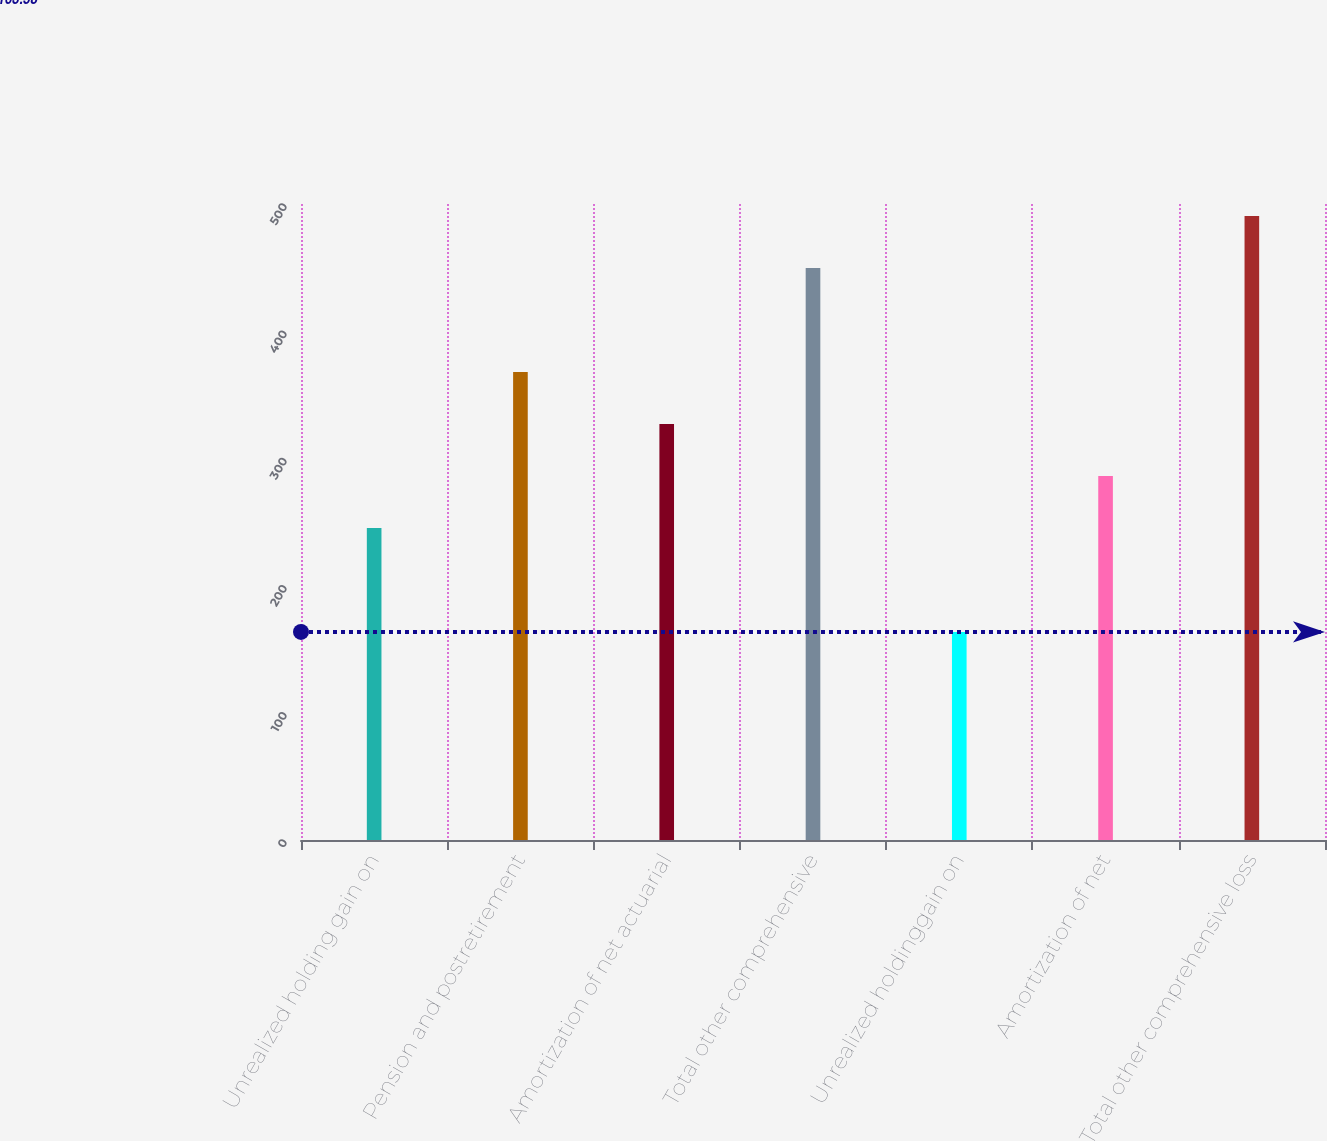Convert chart to OTSL. <chart><loc_0><loc_0><loc_500><loc_500><bar_chart><fcel>Unrealized holding gain on<fcel>Pension and postretirement<fcel>Amortization of net actuarial<fcel>Total other comprehensive<fcel>Unrealized holdinggain on<fcel>Amortization of net<fcel>Total other comprehensive loss<nl><fcel>245.32<fcel>367.93<fcel>327.06<fcel>449.67<fcel>163.58<fcel>286.19<fcel>490.54<nl></chart> 